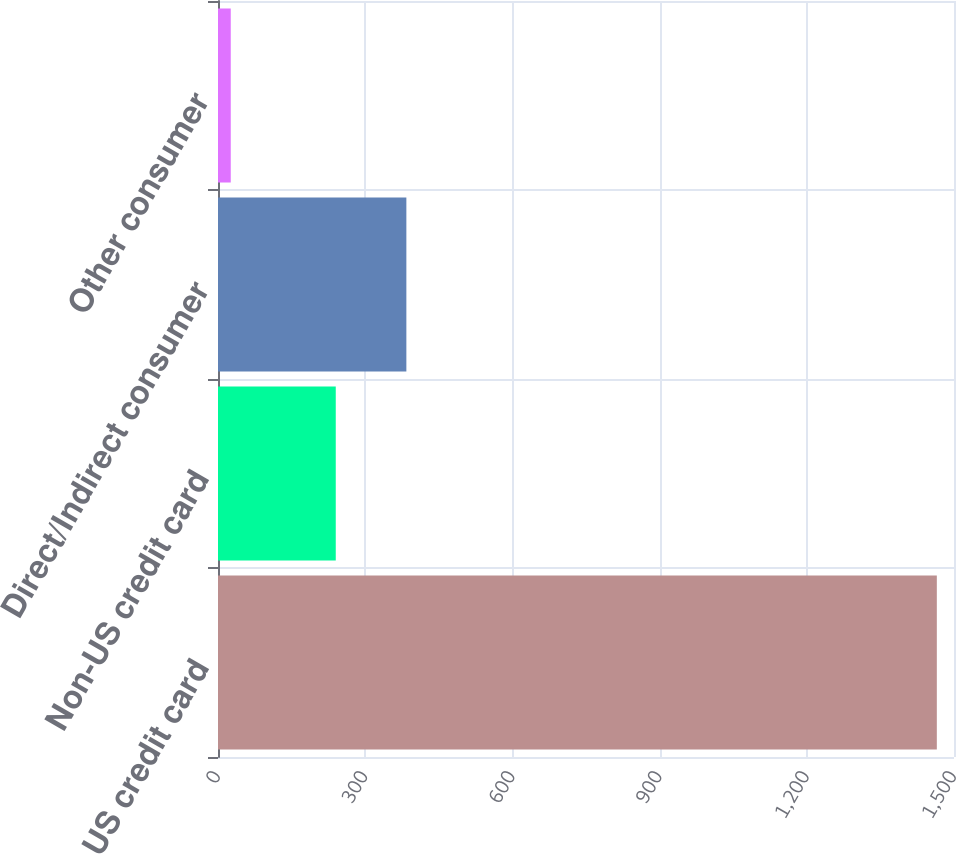Convert chart to OTSL. <chart><loc_0><loc_0><loc_500><loc_500><bar_chart><fcel>US credit card<fcel>Non-US credit card<fcel>Direct/Indirect consumer<fcel>Other consumer<nl><fcel>1465<fcel>240<fcel>383.9<fcel>26<nl></chart> 